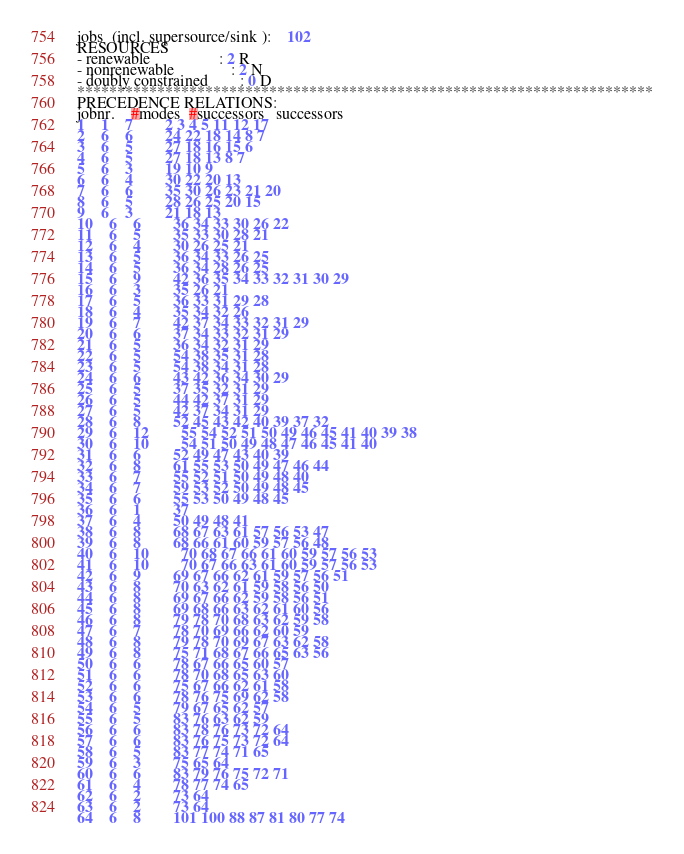Convert code to text. <code><loc_0><loc_0><loc_500><loc_500><_ObjectiveC_>jobs  (incl. supersource/sink ):	102
RESOURCES
- renewable                 : 2 R
- nonrenewable              : 2 N
- doubly constrained        : 0 D
************************************************************************
PRECEDENCE RELATIONS:
jobnr.    #modes  #successors   successors
1	1	7		2 3 4 5 11 12 17 
2	6	6		24 22 18 14 8 7 
3	6	5		27 18 16 15 6 
4	6	5		27 18 13 8 7 
5	6	3		19 10 9 
6	6	4		30 22 20 13 
7	6	6		35 30 26 23 21 20 
8	6	5		28 26 25 20 15 
9	6	3		21 18 13 
10	6	6		36 34 33 30 26 22 
11	6	5		35 33 30 28 21 
12	6	4		30 26 25 21 
13	6	5		36 34 33 26 25 
14	6	5		36 34 28 26 25 
15	6	9		42 36 35 34 33 32 31 30 29 
16	6	3		35 26 21 
17	6	5		36 33 31 29 28 
18	6	4		35 34 32 26 
19	6	7		42 37 34 33 32 31 29 
20	6	6		37 34 33 32 31 29 
21	6	5		36 34 32 31 29 
22	6	5		54 38 35 31 28 
23	6	5		54 38 34 31 28 
24	6	6		43 42 36 34 30 29 
25	6	5		37 35 32 31 29 
26	6	5		44 42 37 31 29 
27	6	5		42 37 34 31 29 
28	6	8		52 45 43 42 40 39 37 32 
29	6	12		55 54 52 51 50 49 46 45 41 40 39 38 
30	6	10		54 51 50 49 48 47 46 45 41 40 
31	6	6		52 49 47 43 40 39 
32	6	8		61 55 53 50 49 47 46 44 
33	6	7		55 52 51 50 49 48 40 
34	6	7		59 53 52 50 49 48 45 
35	6	6		55 53 50 49 48 45 
36	6	1		37 
37	6	4		50 49 48 41 
38	6	8		68 67 63 61 57 56 53 47 
39	6	8		68 66 61 60 59 57 56 48 
40	6	10		70 68 67 66 61 60 59 57 56 53 
41	6	10		70 67 66 63 61 60 59 57 56 53 
42	6	9		69 67 66 62 61 59 57 56 51 
43	6	8		70 63 62 61 59 58 56 50 
44	6	8		69 67 66 62 59 58 56 51 
45	6	8		69 68 66 63 62 61 60 56 
46	6	8		79 78 70 68 63 62 59 58 
47	6	7		78 70 69 66 62 60 59 
48	6	8		79 78 70 69 67 63 62 58 
49	6	8		75 71 68 67 66 65 63 56 
50	6	6		78 67 66 65 60 57 
51	6	6		78 70 68 65 63 60 
52	6	6		75 67 66 62 61 58 
53	6	6		78 76 75 69 62 58 
54	6	5		79 67 65 62 57 
55	6	5		83 76 63 62 59 
56	6	6		83 78 76 73 72 64 
57	6	6		83 76 75 73 72 64 
58	6	5		83 77 74 71 65 
59	6	3		75 65 64 
60	6	6		83 79 76 75 72 71 
61	6	4		78 77 74 65 
62	6	2		73 64 
63	6	2		73 64 
64	6	8		101 100 88 87 81 80 77 74 </code> 